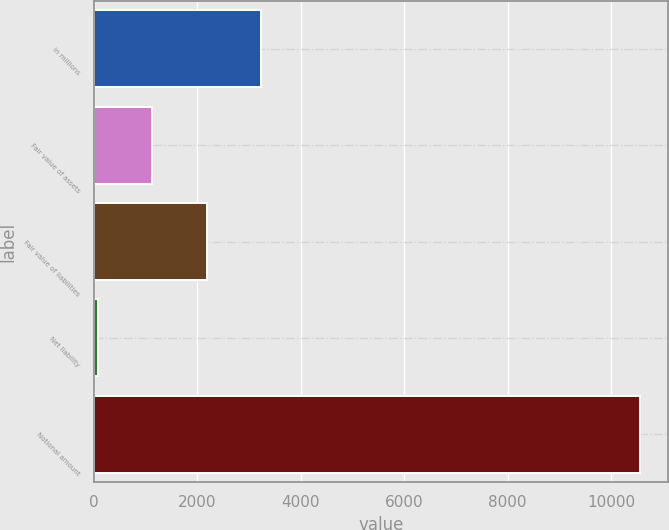<chart> <loc_0><loc_0><loc_500><loc_500><bar_chart><fcel>in millions<fcel>Fair value of assets<fcel>Fair value of liabilities<fcel>Net liability<fcel>Notional amount<nl><fcel>3224.7<fcel>1126.9<fcel>2175.8<fcel>78<fcel>10567<nl></chart> 